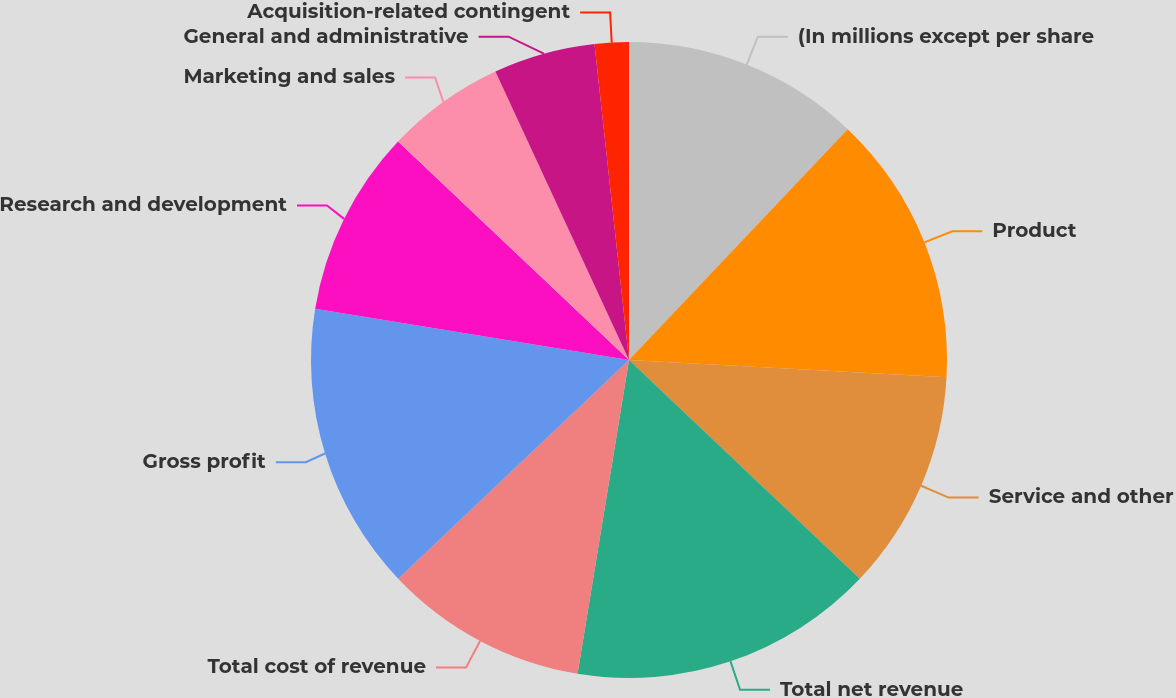Convert chart to OTSL. <chart><loc_0><loc_0><loc_500><loc_500><pie_chart><fcel>(In millions except per share<fcel>Product<fcel>Service and other<fcel>Total net revenue<fcel>Total cost of revenue<fcel>Gross profit<fcel>Research and development<fcel>Marketing and sales<fcel>General and administrative<fcel>Acquisition-related contingent<nl><fcel>12.07%<fcel>13.79%<fcel>11.21%<fcel>15.51%<fcel>10.34%<fcel>14.65%<fcel>9.48%<fcel>6.04%<fcel>5.17%<fcel>1.73%<nl></chart> 